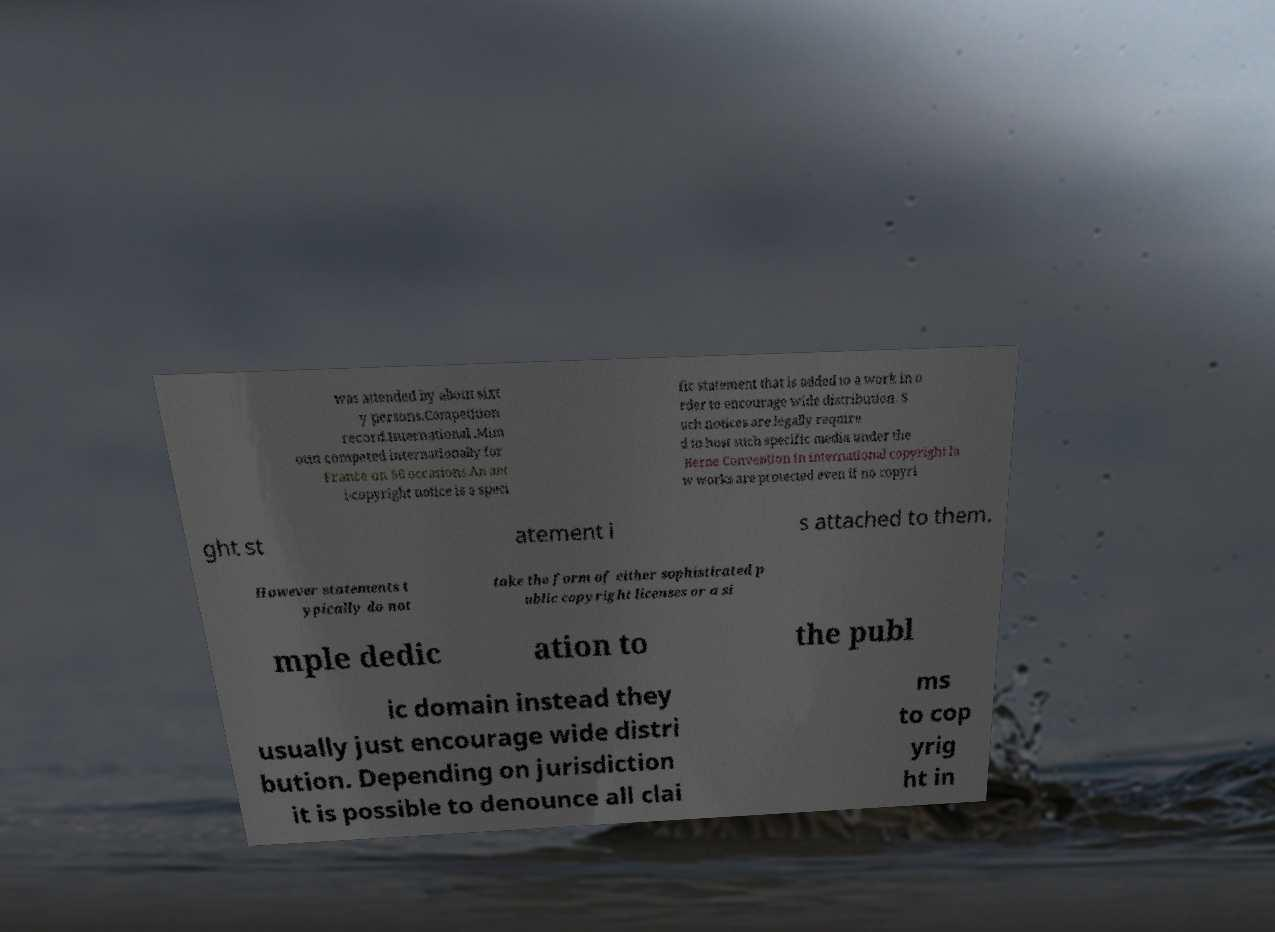Could you assist in decoding the text presented in this image and type it out clearly? was attended by about sixt y persons.Competition record.International .Mim oun competed internationally for France on 86 occasions.An ant i-copyright notice is a speci fic statement that is added to a work in o rder to encourage wide distribution. S uch notices are legally require d to host such specific media under the Berne Convention in international copyright la w works are protected even if no copyri ght st atement i s attached to them. However statements t ypically do not take the form of either sophisticated p ublic copyright licenses or a si mple dedic ation to the publ ic domain instead they usually just encourage wide distri bution. Depending on jurisdiction it is possible to denounce all clai ms to cop yrig ht in 